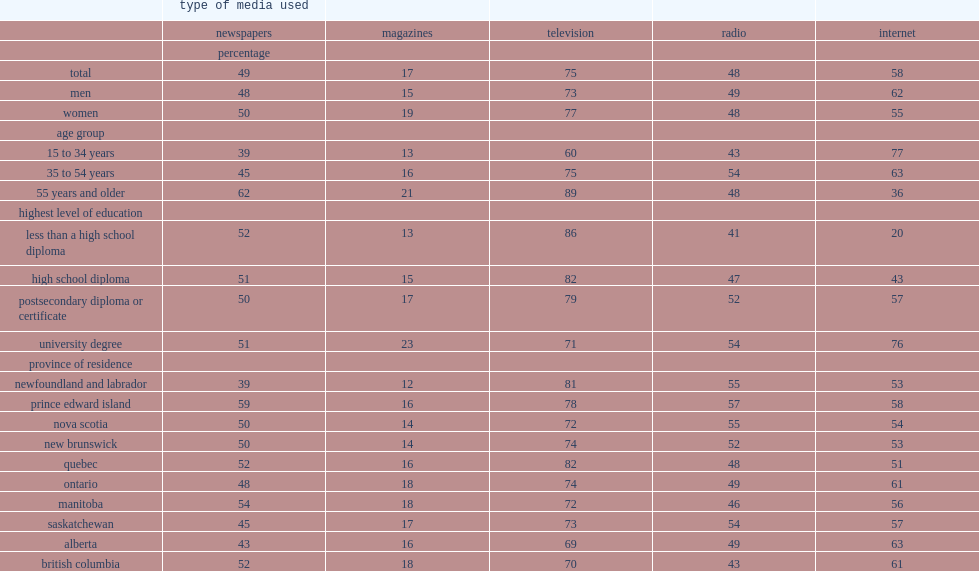Who were more likely to stay informed by reading magazines, man or woman? Women. Who were more likely to watch television, man or woman? Women. Who were more likely to used the internet, man or woman? Men. How many percentage point of university graduates followed news and current affairs on the internet? 76.0. How many percentage point of people whose highest level of education is a high school diploma followed news and current affairs on the internet? 43.0. How many percentage point of people whose highest level of education is a high school diploma watched television to stay informed? 82.0. How many percentage point of university graduates watched television to stay informed? 71.0. How many percentage point of people in alberta followed news and current affairs on the internet? 63.0. How many percentage point of people in british columbia followed news and current affairs on the internet? 61.0. How many percentage point of people in ontario followed news and current affairs on the internet? 61.0. How many percentage point of people in quebec used the internet? 51.0. How many percentage point of people in prince edward island used radio? 57.0. How many percentage point of people in newfoundland and labrador used radio? 55.0. How many percentage point of people in nova scotia used radio? 55.0. How many percentage point of people in british columbia used radio? 43.0. What was the proportion of people in quebec watched news and current affairs on television? 82.0. What was the proportion of people in british columbia watched news and current affairs on television? 70.0. What was the proportion of people in alberta watched news and current affairs on television? 69.0. 